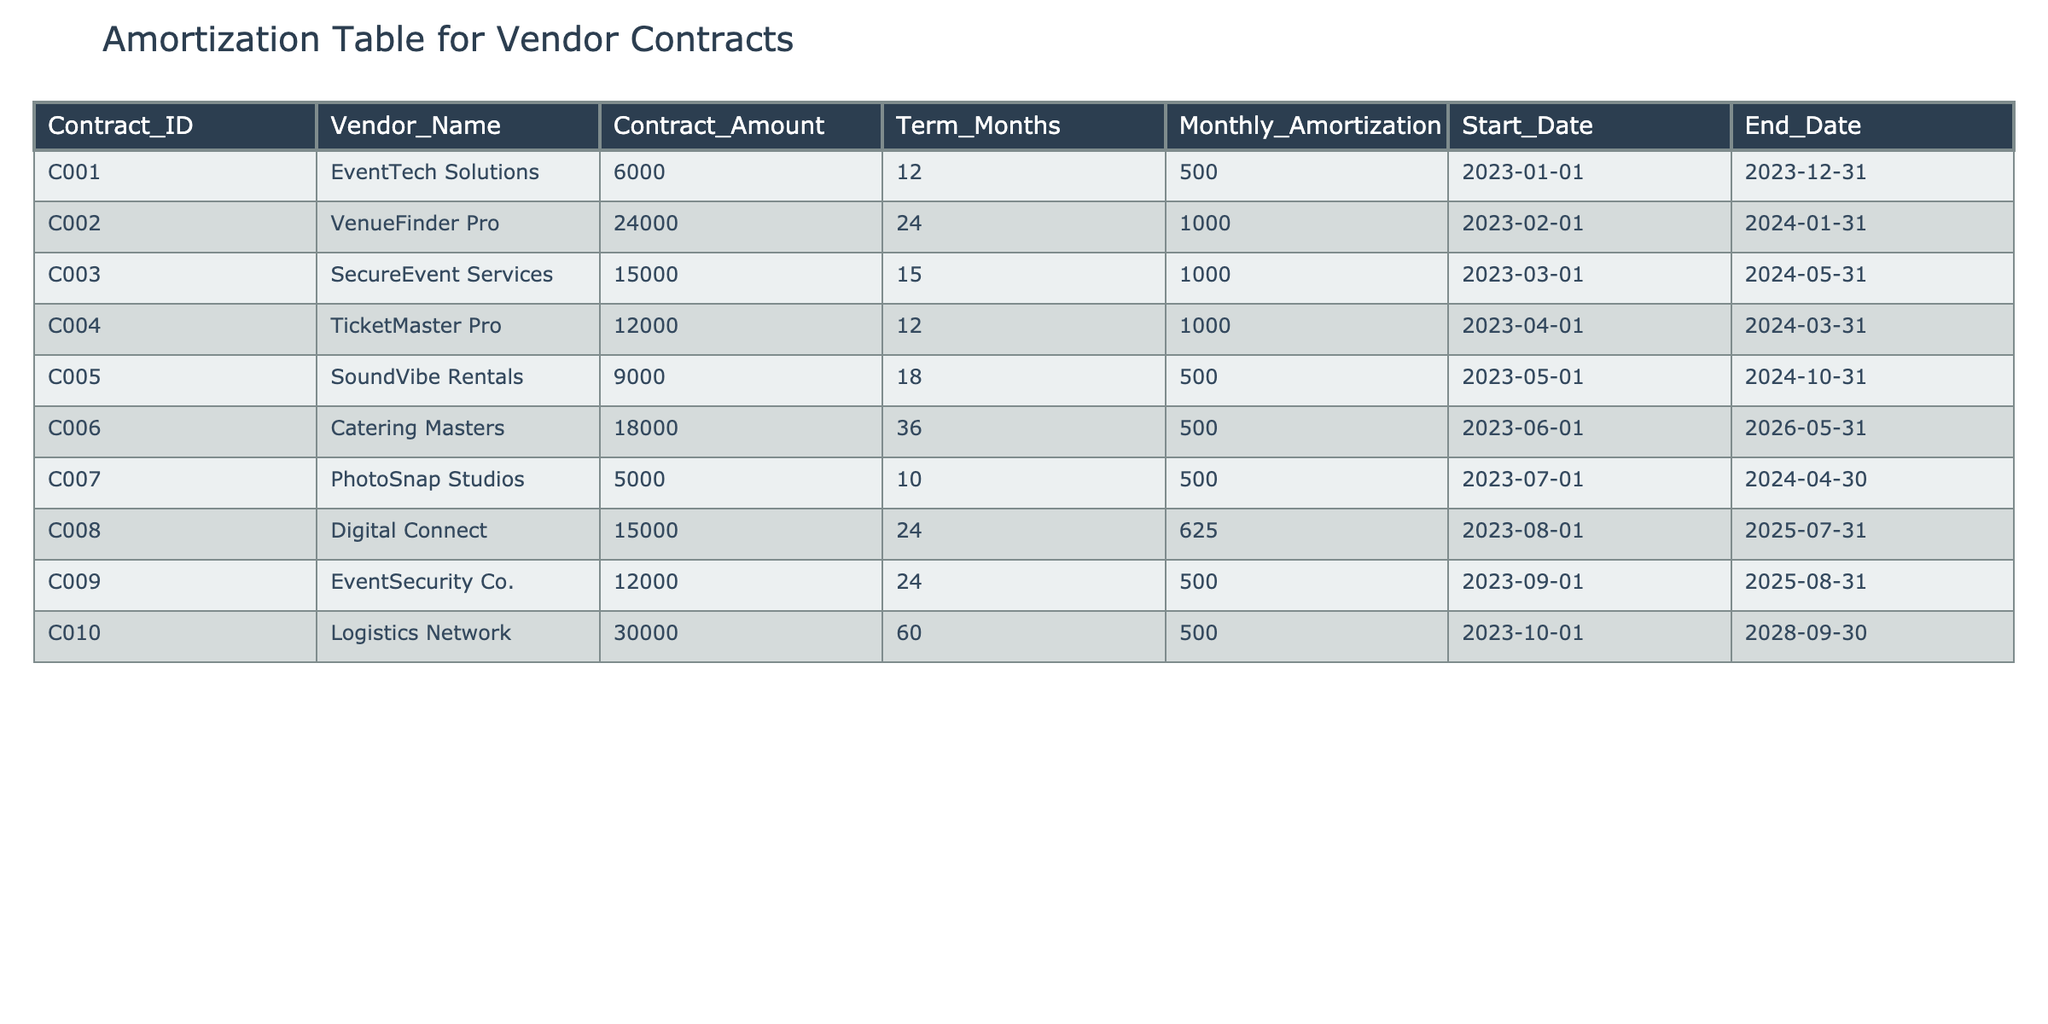What is the total contract amount for all vendors? To find the total contract amount, add up all the contract amounts listed in the table: 6000 + 24000 + 15000 + 12000 + 9000 + 18000 + 5000 + 15000 + 12000 + 30000 = 109000.
Answer: 109000 Which vendor has the longest contract term? The longest contract term is 60 months, which corresponds to the Logistics Network contract. By examining the Term_Months column, we find that Logistics Network (C010) has the highest value.
Answer: Logistics Network What is the average monthly amortization across all contracts? To find the average monthly amortization, sum all the monthly amortization values: 500 + 1000 + 1000 + 1000 + 500 + 500 + 500 + 625 + 500 + 500 = 6225. Divide this total by the number of contracts (10) to find the average: 6225 / 10 = 622.5.
Answer: 622.5 Is there any contract with a monthly amortization greater than 1000? By examining the Monthly_Amortization column, we see that there are three contracts (C002, C003, C004) with amounts equal to or greater than 1000. Therefore, the answer is yes.
Answer: Yes How many vendors have contracts with a term of over 24 months? Check the Term_Months column, where the values are 36 and 60 (C006 and C010). Additionally, there’s C002 (24 months) that counts as equal but not over. Counting values above 24 gives us two vendors: C006 and C010.
Answer: 2 What is the total amortization amount for contracts that start in 2023? To find this, include all contracts that start in 2023 and sum their monthly amortizations. The contracts C001, C002, C003, C004, C005, C006, C007, C008, C009, and C010 all started in 2023. Thus, the total amortization for all contracts is 6225, calculated earlier, covering them all.
Answer: 6225 Which vendor's contract ends this year (2023)? To check this, look at the End_Date column. From the data, C001 (EventTech Solutions), C004 (TicketMaster Pro), and C007 (PhotoSnap Studios) have end dates in 2023.
Answer: 3 contracts What is the total contract amount for contracts ending in 2025? From the contracts, the only vendors ending in 2025 are C008 (Digital Connect) and C009 (EventSecurity Co.). Adding their contract amounts: 15000 + 12000 = 27000.
Answer: 27000 